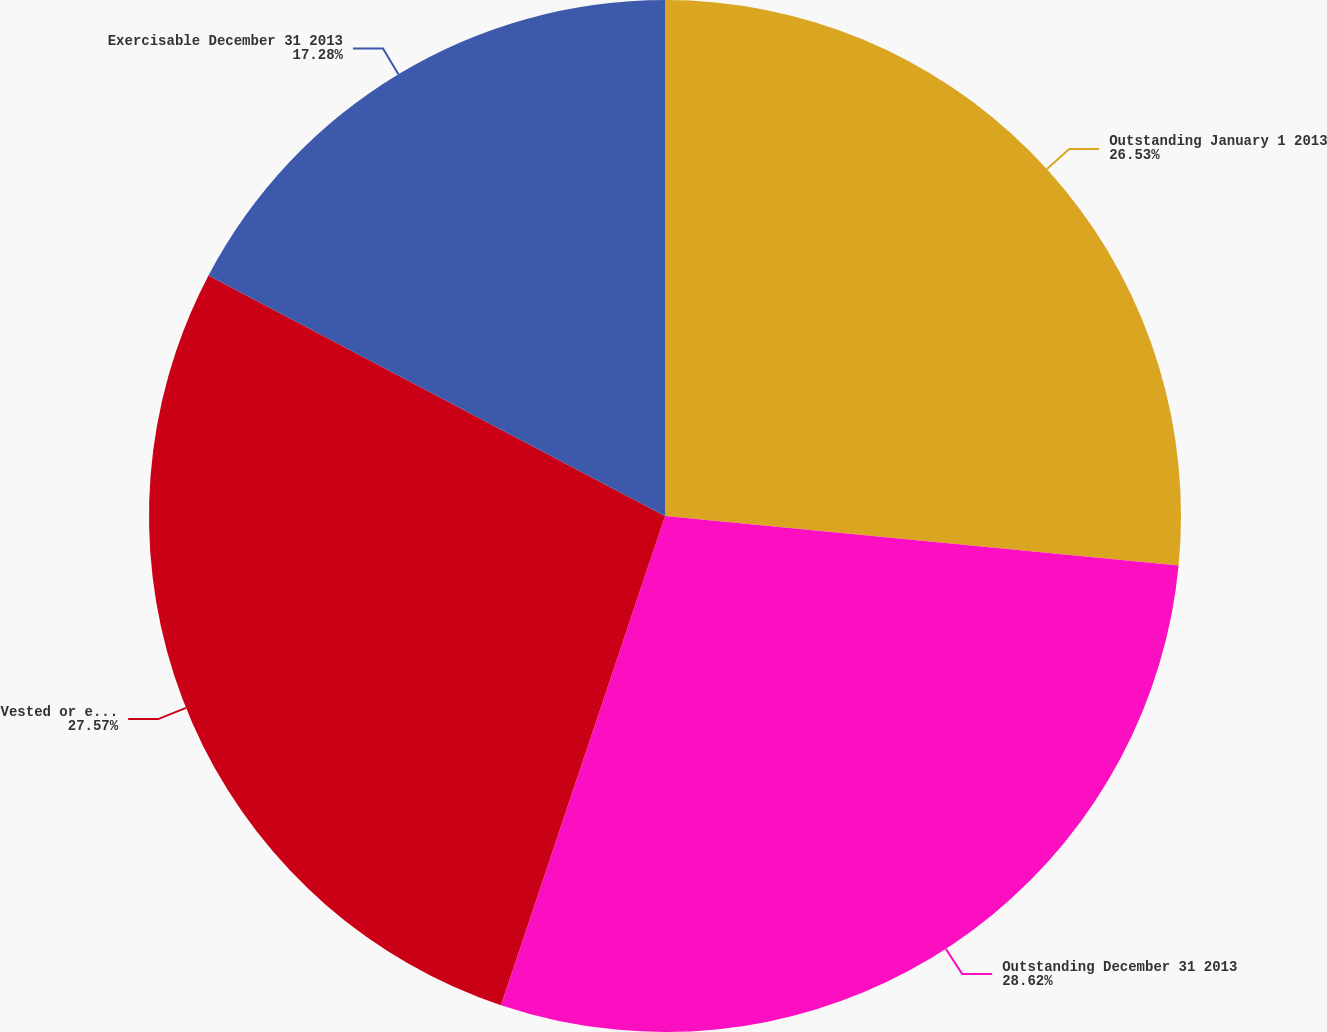Convert chart to OTSL. <chart><loc_0><loc_0><loc_500><loc_500><pie_chart><fcel>Outstanding January 1 2013<fcel>Outstanding December 31 2013<fcel>Vested or expected to vest<fcel>Exercisable December 31 2013<nl><fcel>26.53%<fcel>28.62%<fcel>27.57%<fcel>17.28%<nl></chart> 